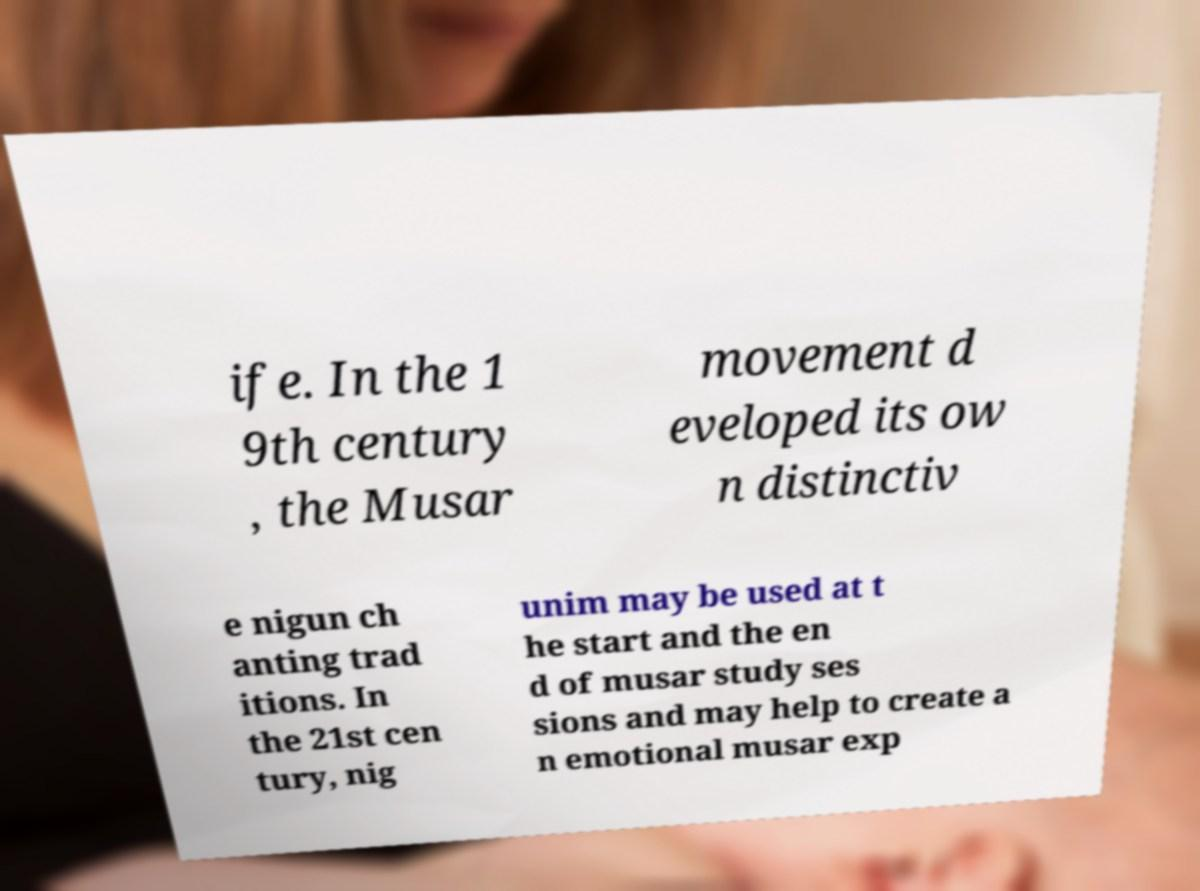Could you assist in decoding the text presented in this image and type it out clearly? ife. In the 1 9th century , the Musar movement d eveloped its ow n distinctiv e nigun ch anting trad itions. In the 21st cen tury, nig unim may be used at t he start and the en d of musar study ses sions and may help to create a n emotional musar exp 